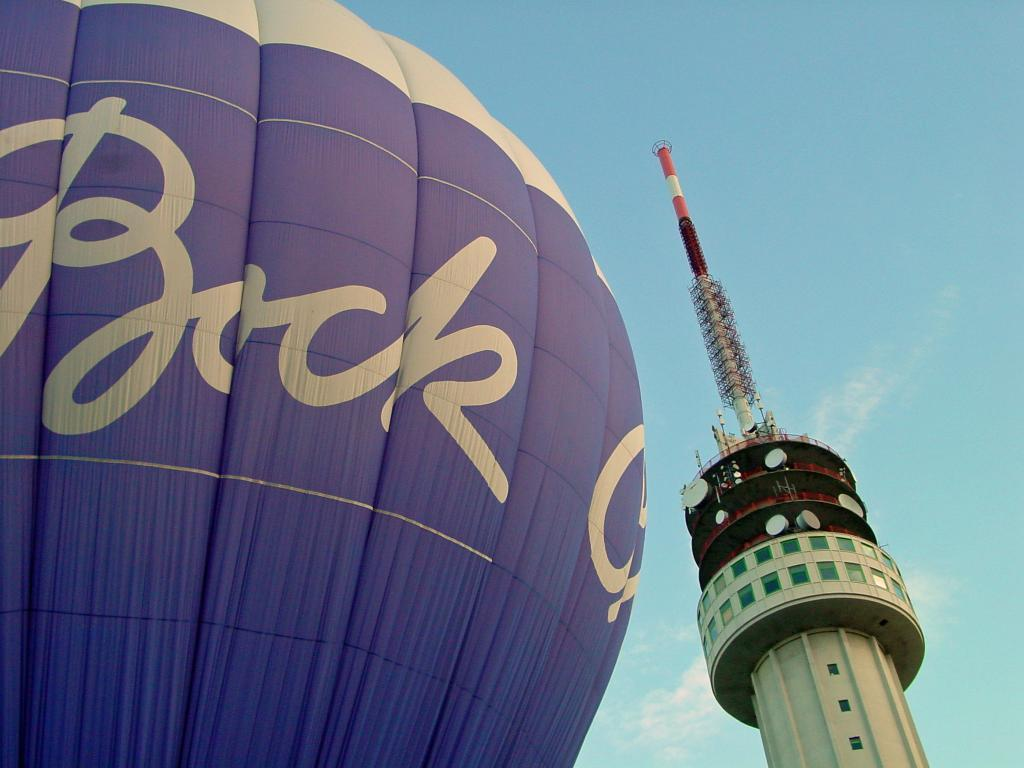What is the main structure in the image? There is a tower in the image. What else can be seen in the image besides the tower? There is a hot air balloon in the image. Where is the hot air balloon located in the image? The hot air balloon is on the left side of the image. What colors are used for the hot air balloon? The hot air balloon is white and blue in color. Is there any text on the hot air balloon? Yes, there is text on the hot air balloon. How would you describe the sky in the image? The sky is blue and cloudy. What type of teaching is happening in the hot air balloon? There is no teaching happening in the hot air balloon, as it is not depicted in the image. 